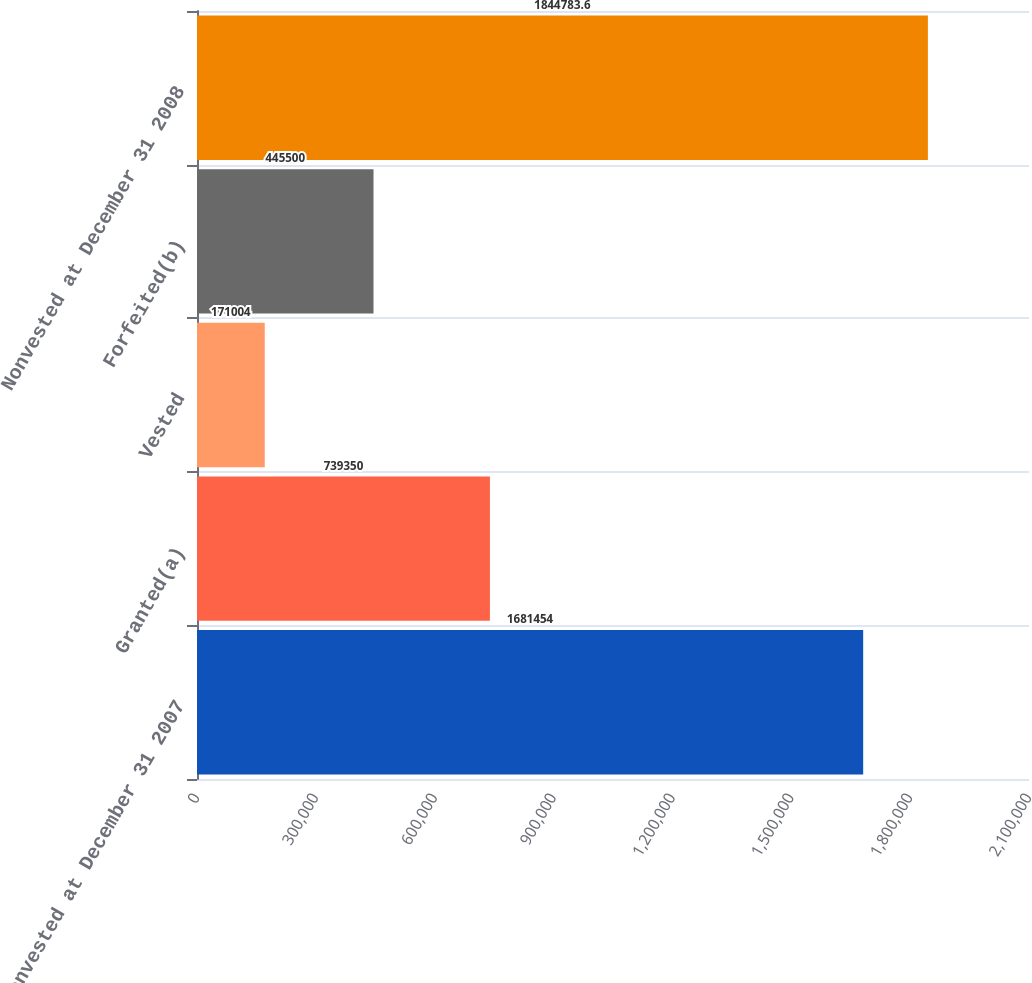Convert chart. <chart><loc_0><loc_0><loc_500><loc_500><bar_chart><fcel>Nonvested at December 31 2007<fcel>Granted(a)<fcel>Vested<fcel>Forfeited(b)<fcel>Nonvested at December 31 2008<nl><fcel>1.68145e+06<fcel>739350<fcel>171004<fcel>445500<fcel>1.84478e+06<nl></chart> 